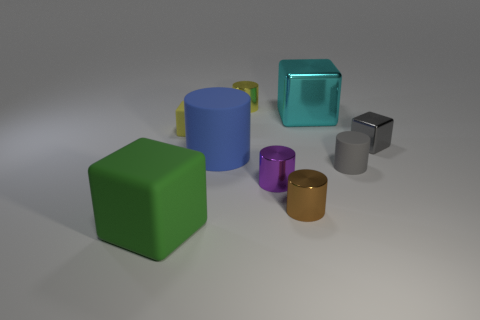How many green shiny things have the same shape as the small yellow metal thing?
Provide a succinct answer. 0. How many objects are either cylinders that are left of the tiny yellow cylinder or small gray things in front of the tiny gray metallic thing?
Make the answer very short. 2. What material is the tiny cylinder behind the small rubber thing that is in front of the object on the right side of the tiny rubber cylinder?
Offer a very short reply. Metal. Is the color of the rubber object that is in front of the brown thing the same as the tiny matte cylinder?
Give a very brief answer. No. What is the material of the cube that is in front of the large cyan object and on the right side of the large blue rubber thing?
Provide a succinct answer. Metal. Is there a cyan cube that has the same size as the gray cube?
Keep it short and to the point. No. How many large cyan cubes are there?
Offer a terse response. 1. How many small yellow shiny cylinders are in front of the gray metal block?
Provide a short and direct response. 0. Is the big green block made of the same material as the brown object?
Ensure brevity in your answer.  No. What number of small metallic things are to the right of the tiny purple metal cylinder and to the left of the tiny metallic cube?
Provide a succinct answer. 1. 